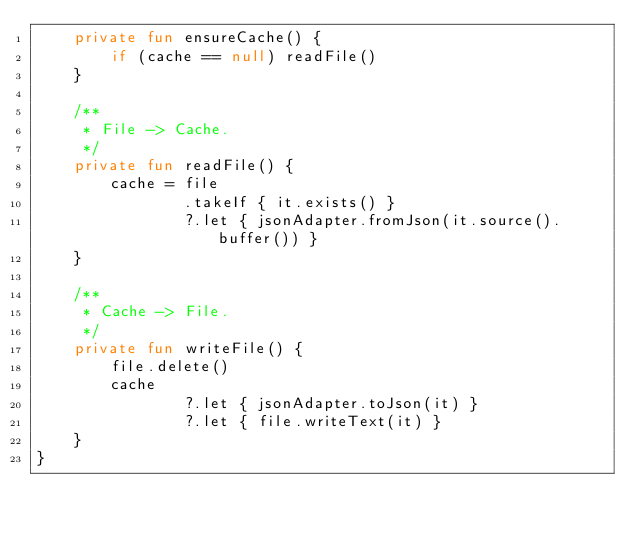Convert code to text. <code><loc_0><loc_0><loc_500><loc_500><_Kotlin_>    private fun ensureCache() {
        if (cache == null) readFile()
    }

    /**
     * File -> Cache.
     */
    private fun readFile() {
        cache = file
                .takeIf { it.exists() }
                ?.let { jsonAdapter.fromJson(it.source().buffer()) }
    }

    /**
     * Cache -> File.
     */
    private fun writeFile() {
        file.delete()
        cache
                ?.let { jsonAdapter.toJson(it) }
                ?.let { file.writeText(it) }
    }
}
</code> 